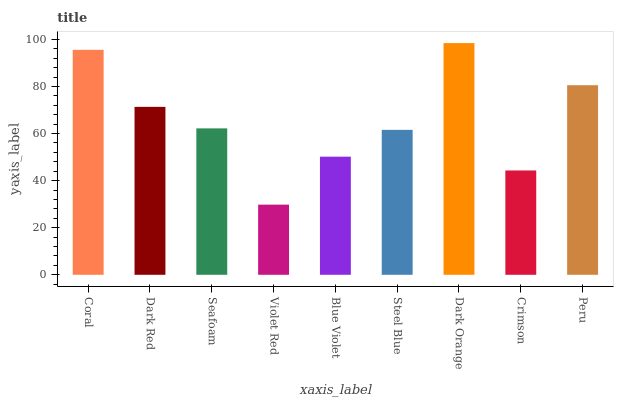Is Violet Red the minimum?
Answer yes or no. Yes. Is Dark Orange the maximum?
Answer yes or no. Yes. Is Dark Red the minimum?
Answer yes or no. No. Is Dark Red the maximum?
Answer yes or no. No. Is Coral greater than Dark Red?
Answer yes or no. Yes. Is Dark Red less than Coral?
Answer yes or no. Yes. Is Dark Red greater than Coral?
Answer yes or no. No. Is Coral less than Dark Red?
Answer yes or no. No. Is Seafoam the high median?
Answer yes or no. Yes. Is Seafoam the low median?
Answer yes or no. Yes. Is Violet Red the high median?
Answer yes or no. No. Is Dark Orange the low median?
Answer yes or no. No. 